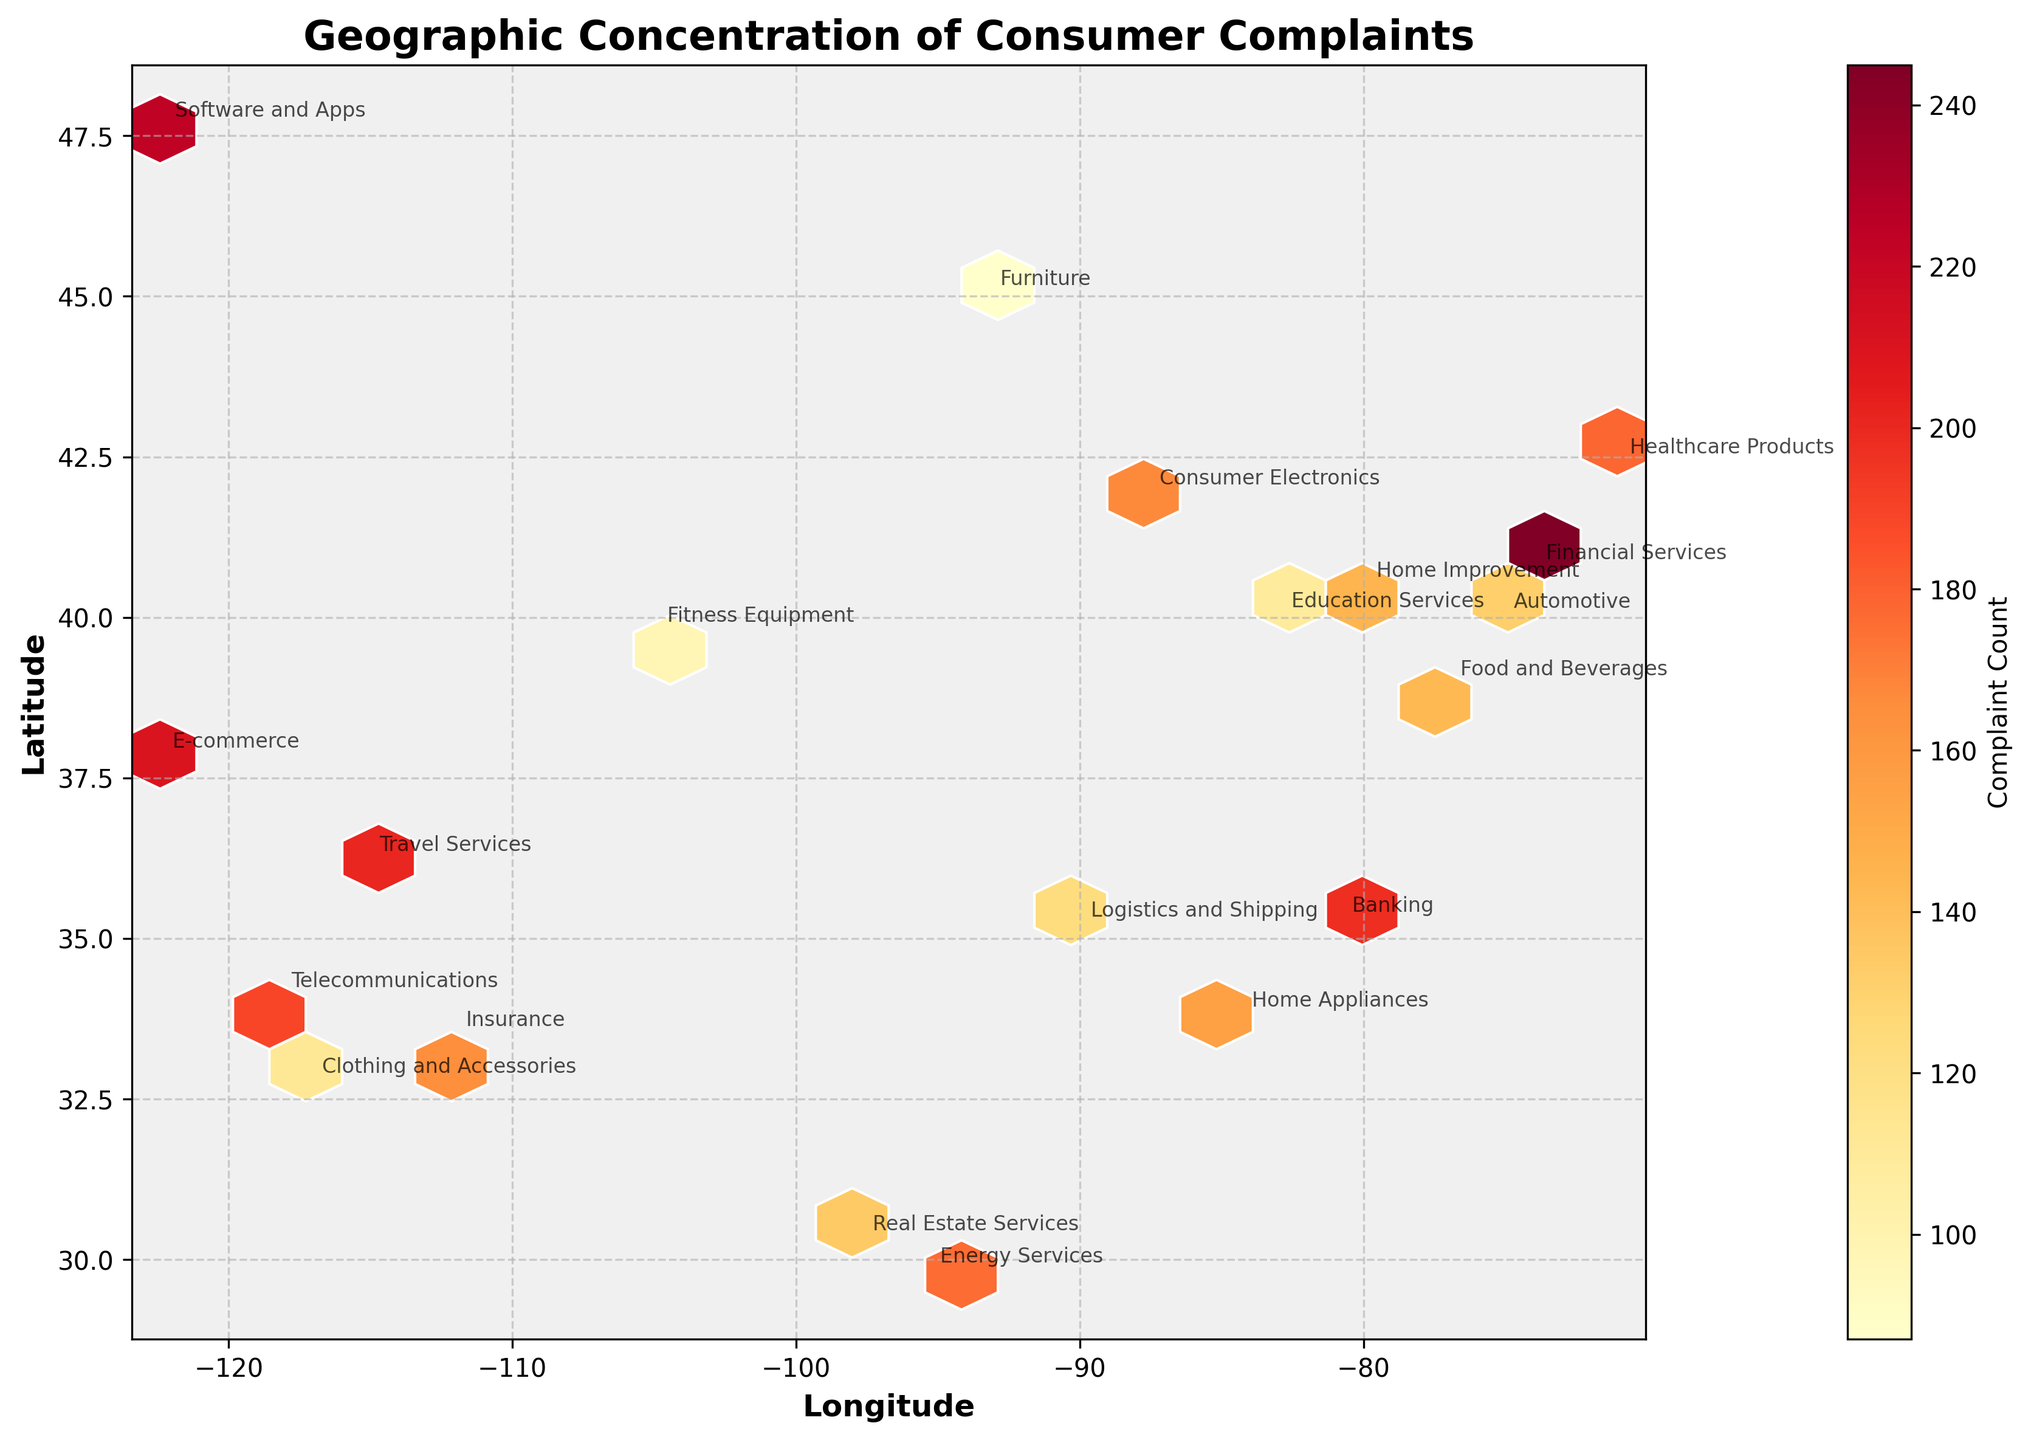what is the title of the figure? The title can be found at the top of the figure. It summarizes what the chart is about.
Answer: Geographic Concentration of Consumer Complaints How many product categories are displayed on the plot? Each annotated label corresponds to a different product category. Count the number of unique labels on the plot.
Answer: 20 Which product category has the highest number of complaints, and where is it located geographically? Identify the label that corresponds to the highest value in the color scale and locate its geographical coordinates in the plot.
Answer: Financial Services, New York City (40.7128, -74.0060) What are the ranges for the longitude and latitude axes? These ranges can be found on the x-axis and y-axis of the plot, respectively.
Answer: Longitude: approx. [-123, -73], Latitude: approx. [29, 48] Which city has the second highest number of complaints? Look for the second highest regions based on the color intensity from the color scale, then identify the corresponding city label.
Answer: Seattle (47.6062, -122.3321, Software and Apps) How is the complaint count represented visually on the plot? Examine how different areas on the map are colored and describe the color representation.
Answer: By hexbin color intensity; darker colors represent higher complaint counts Between Financial Services and Software and Apps, which product has more complaints and by how much? Identify the complaint counts from their respective locations and subtract to find the difference.
Answer: Financial Services has 21 more complaints (245 - 224) What do the color shades represent in the plot? The color bar on the right side of the plot indicates what different shades represent in terms of data.
Answer: Complaint Count How many complaints are there from the Healthcare Products category, and where is it located? Find the label "Healthcare Products" in the plot, then note the corresponding complaint count from color scale and coordinates.
Answer: 178, Boston (42.3601, -71.0589) 